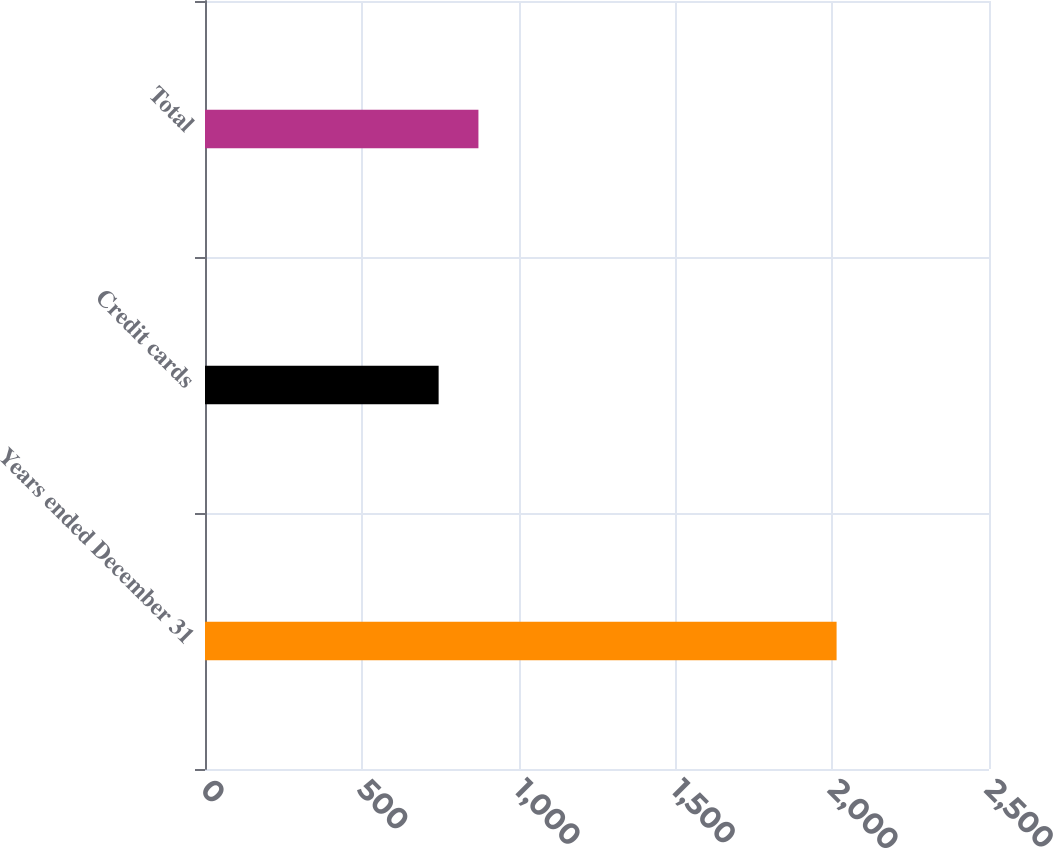Convert chart. <chart><loc_0><loc_0><loc_500><loc_500><bar_chart><fcel>Years ended December 31<fcel>Credit cards<fcel>Total<nl><fcel>2014<fcel>745<fcel>871.9<nl></chart> 